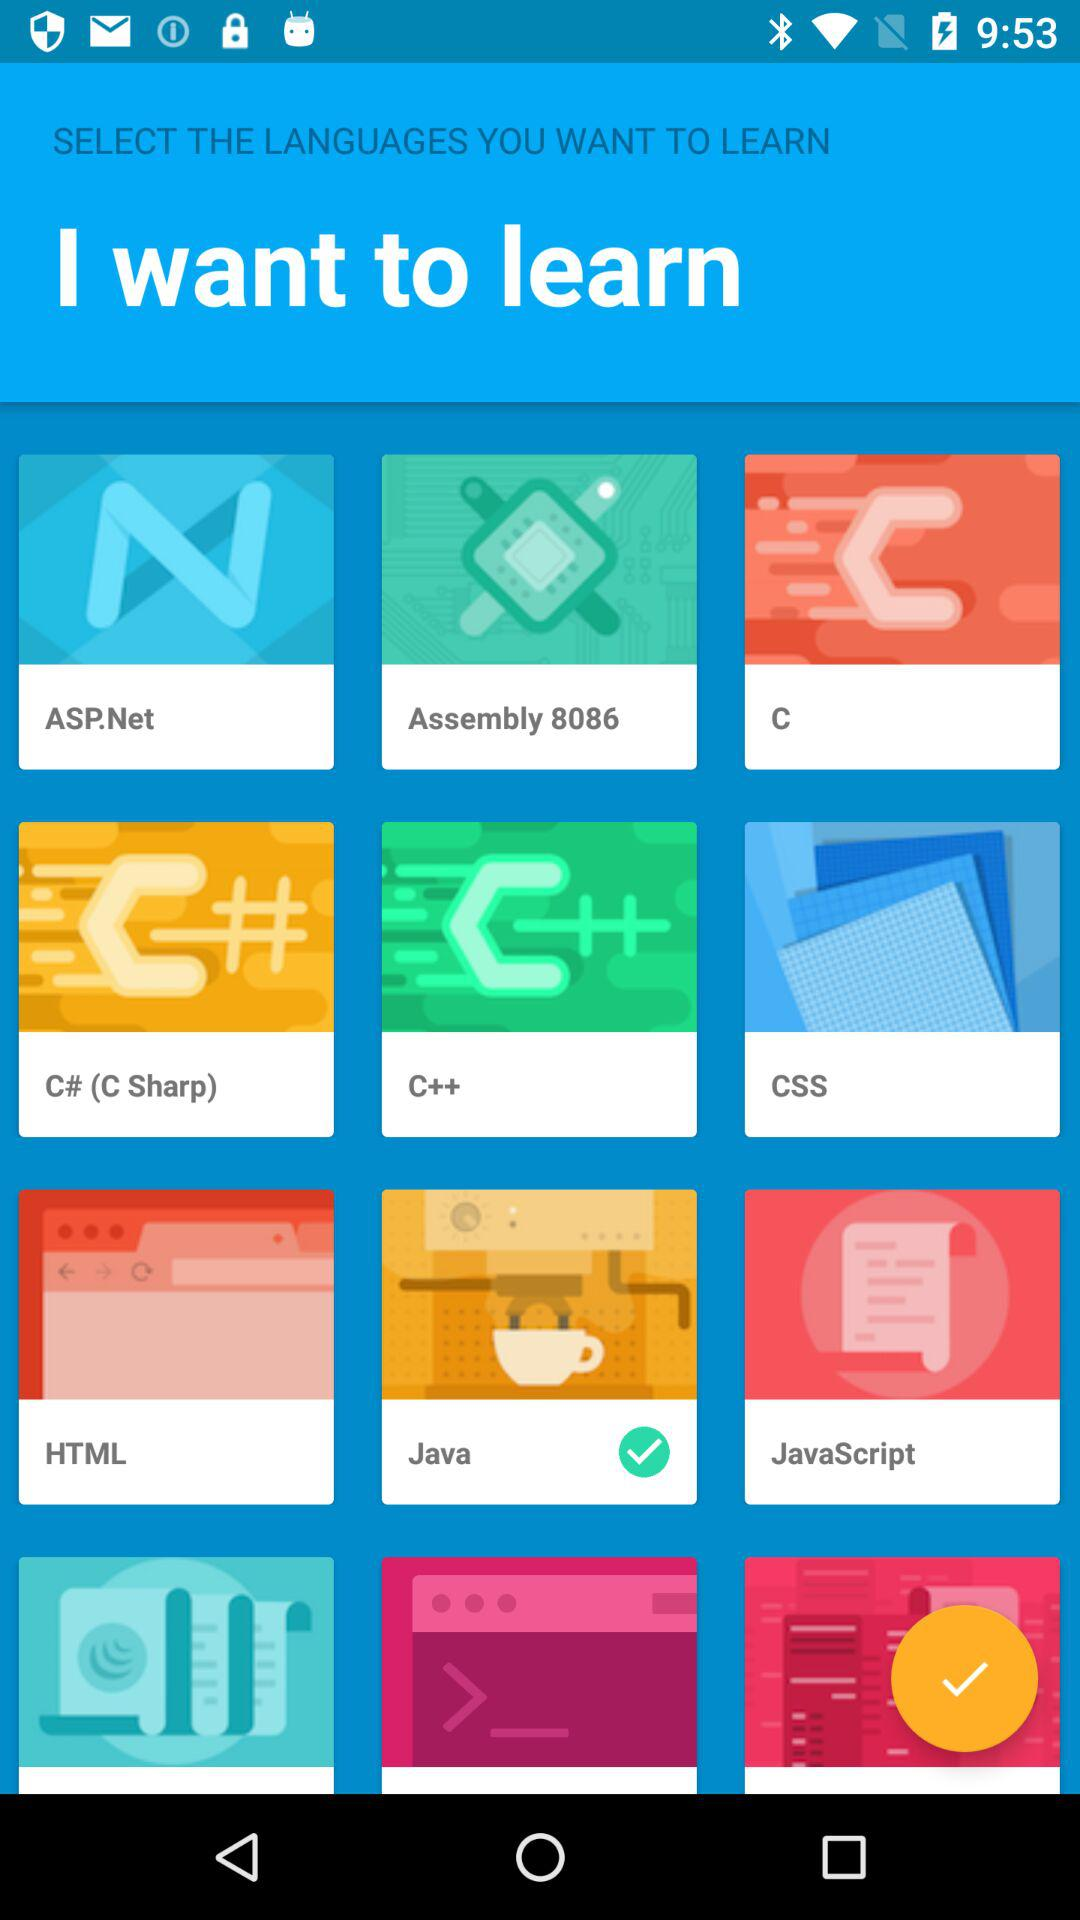Which language has been selected? The language that has been selected is "Java". 